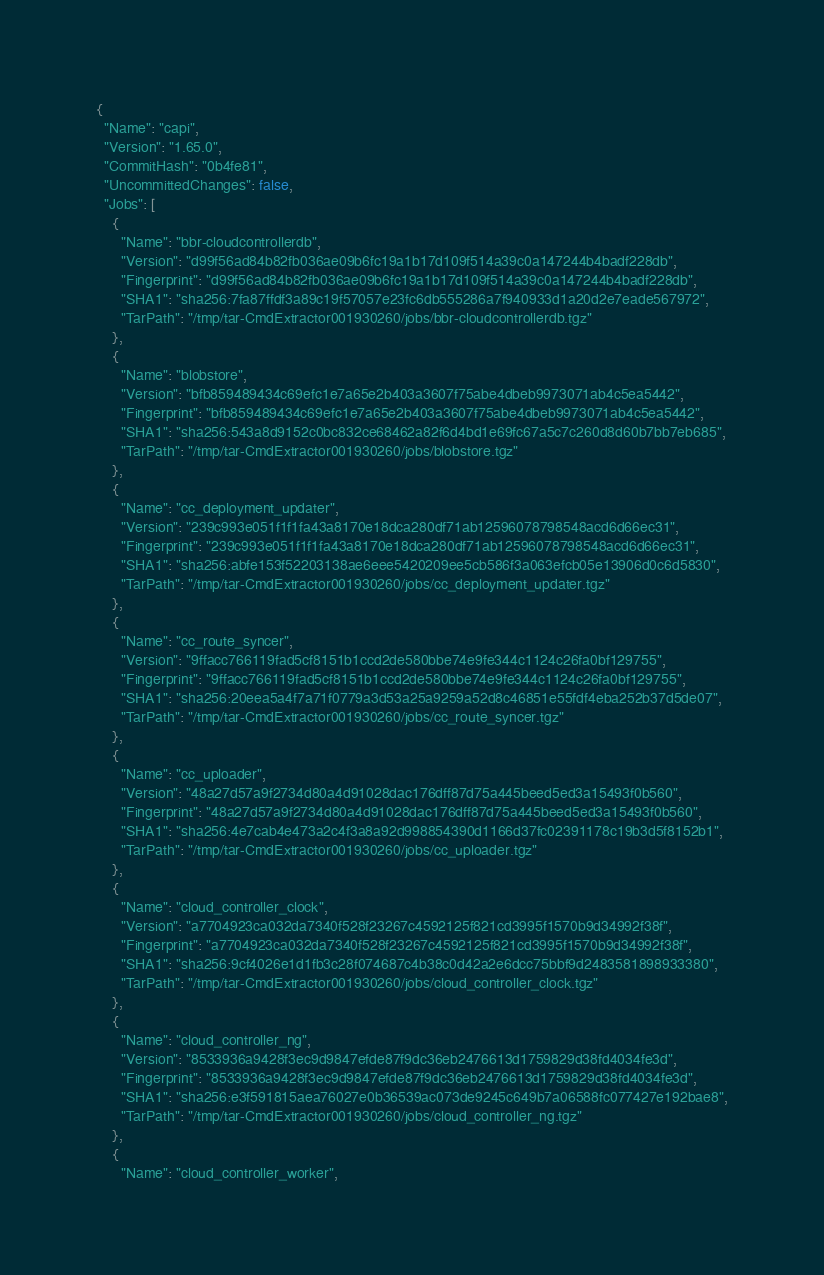<code> <loc_0><loc_0><loc_500><loc_500><_YAML_>{
  "Name": "capi",
  "Version": "1.65.0",
  "CommitHash": "0b4fe81",
  "UncommittedChanges": false,
  "Jobs": [
    {
      "Name": "bbr-cloudcontrollerdb",
      "Version": "d99f56ad84b82fb036ae09b6fc19a1b17d109f514a39c0a147244b4badf228db",
      "Fingerprint": "d99f56ad84b82fb036ae09b6fc19a1b17d109f514a39c0a147244b4badf228db",
      "SHA1": "sha256:7fa87ffdf3a89c19f57057e23fc6db555286a7f940933d1a20d2e7eade567972",
      "TarPath": "/tmp/tar-CmdExtractor001930260/jobs/bbr-cloudcontrollerdb.tgz"
    },
    {
      "Name": "blobstore",
      "Version": "bfb859489434c69efc1e7a65e2b403a3607f75abe4dbeb9973071ab4c5ea5442",
      "Fingerprint": "bfb859489434c69efc1e7a65e2b403a3607f75abe4dbeb9973071ab4c5ea5442",
      "SHA1": "sha256:543a8d9152c0bc832ce68462a82f6d4bd1e69fc67a5c7c260d8d60b7bb7eb685",
      "TarPath": "/tmp/tar-CmdExtractor001930260/jobs/blobstore.tgz"
    },
    {
      "Name": "cc_deployment_updater",
      "Version": "239c993e051f1f1fa43a8170e18dca280df71ab12596078798548acd6d66ec31",
      "Fingerprint": "239c993e051f1f1fa43a8170e18dca280df71ab12596078798548acd6d66ec31",
      "SHA1": "sha256:abfe153f52203138ae6eee5420209ee5cb586f3a063efcb05e13906d0c6d5830",
      "TarPath": "/tmp/tar-CmdExtractor001930260/jobs/cc_deployment_updater.tgz"
    },
    {
      "Name": "cc_route_syncer",
      "Version": "9ffacc766119fad5cf8151b1ccd2de580bbe74e9fe344c1124c26fa0bf129755",
      "Fingerprint": "9ffacc766119fad5cf8151b1ccd2de580bbe74e9fe344c1124c26fa0bf129755",
      "SHA1": "sha256:20eea5a4f7a71f0779a3d53a25a9259a52d8c46851e55fdf4eba252b37d5de07",
      "TarPath": "/tmp/tar-CmdExtractor001930260/jobs/cc_route_syncer.tgz"
    },
    {
      "Name": "cc_uploader",
      "Version": "48a27d57a9f2734d80a4d91028dac176dff87d75a445beed5ed3a15493f0b560",
      "Fingerprint": "48a27d57a9f2734d80a4d91028dac176dff87d75a445beed5ed3a15493f0b560",
      "SHA1": "sha256:4e7cab4e473a2c4f3a8a92d998854390d1166d37fc02391178c19b3d5f8152b1",
      "TarPath": "/tmp/tar-CmdExtractor001930260/jobs/cc_uploader.tgz"
    },
    {
      "Name": "cloud_controller_clock",
      "Version": "a7704923ca032da7340f528f23267c4592125f821cd3995f1570b9d34992f38f",
      "Fingerprint": "a7704923ca032da7340f528f23267c4592125f821cd3995f1570b9d34992f38f",
      "SHA1": "sha256:9cf4026e1d1fb3c28f074687c4b38c0d42a2e6dcc75bbf9d2483581898933380",
      "TarPath": "/tmp/tar-CmdExtractor001930260/jobs/cloud_controller_clock.tgz"
    },
    {
      "Name": "cloud_controller_ng",
      "Version": "8533936a9428f3ec9d9847efde87f9dc36eb2476613d1759829d38fd4034fe3d",
      "Fingerprint": "8533936a9428f3ec9d9847efde87f9dc36eb2476613d1759829d38fd4034fe3d",
      "SHA1": "sha256:e3f591815aea76027e0b36539ac073de9245c649b7a06588fc077427e192bae8",
      "TarPath": "/tmp/tar-CmdExtractor001930260/jobs/cloud_controller_ng.tgz"
    },
    {
      "Name": "cloud_controller_worker",</code> 